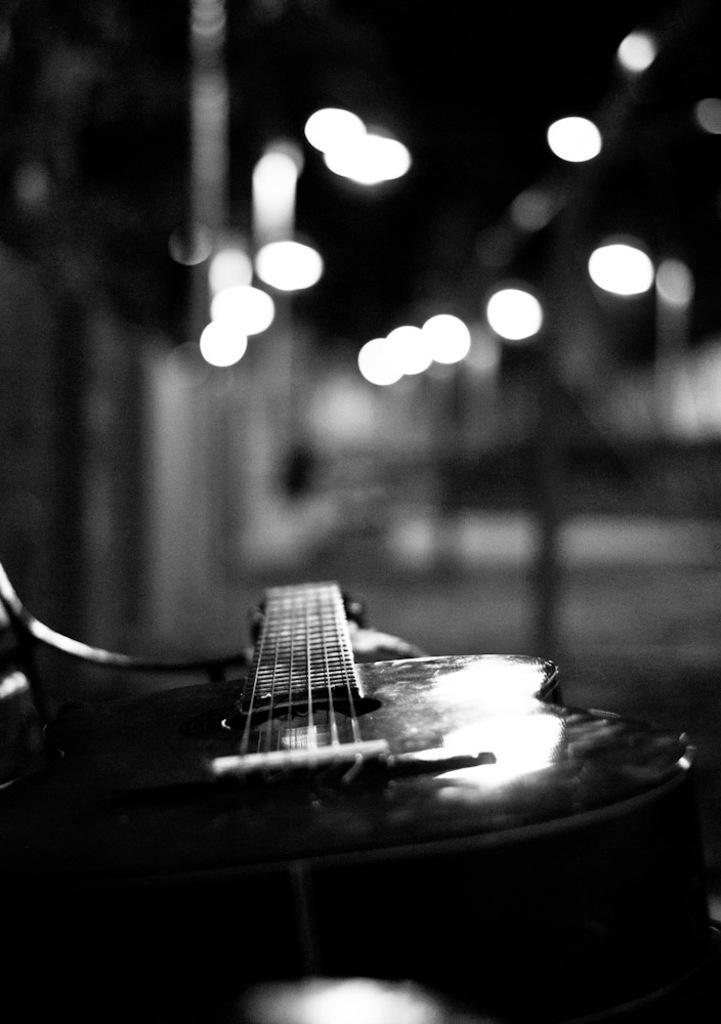Please provide a concise description of this image. here we can see a guitar on the ground, and at above there are lights. 